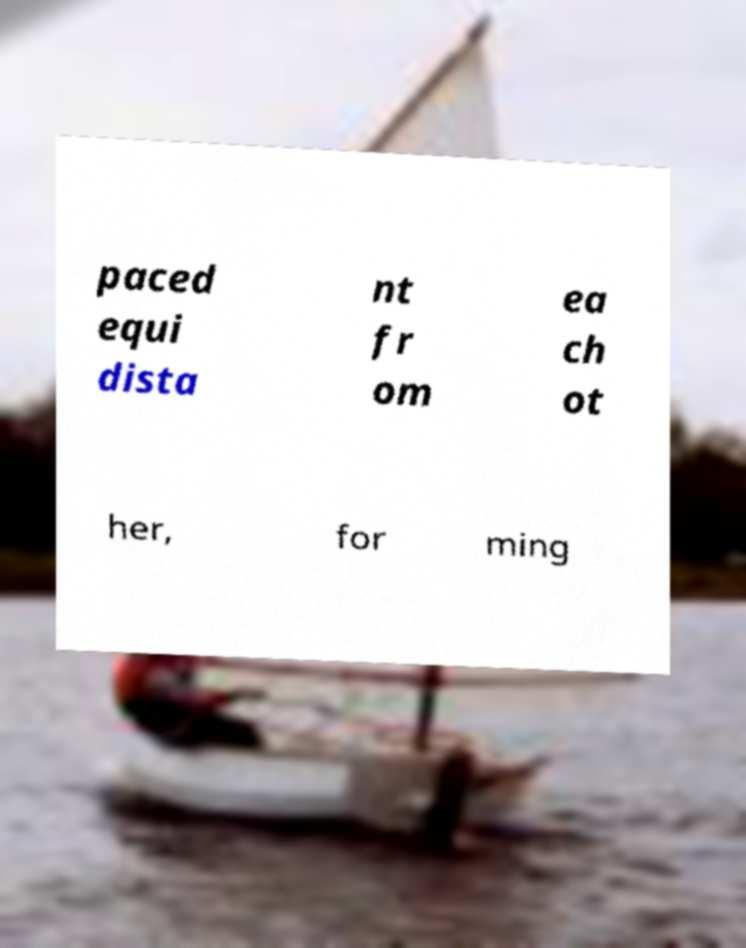Can you read and provide the text displayed in the image?This photo seems to have some interesting text. Can you extract and type it out for me? paced equi dista nt fr om ea ch ot her, for ming 